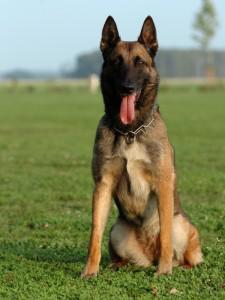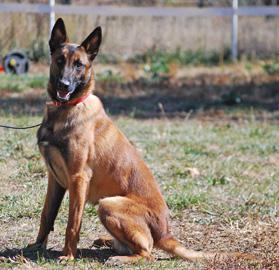The first image is the image on the left, the second image is the image on the right. Given the left and right images, does the statement "There are three dogs in one of the images." hold true? Answer yes or no. No. 